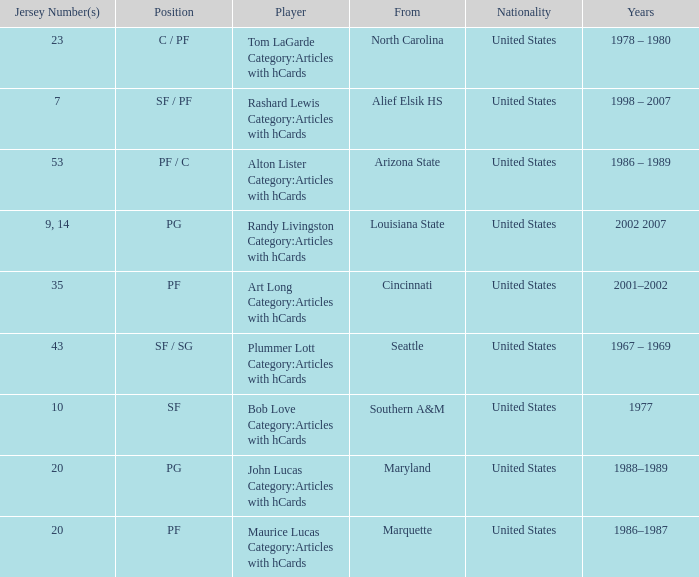Tom Lagarde Category:Articles with hCards used what Jersey Number(s)? 23.0. 